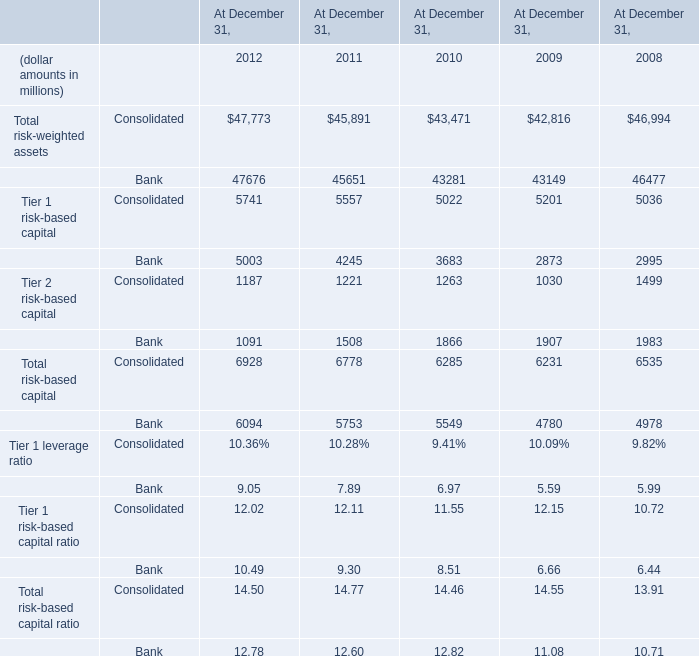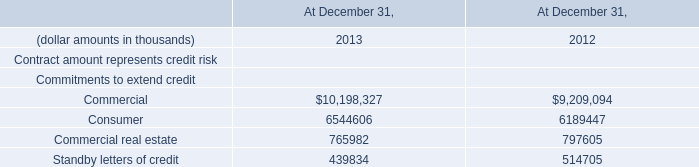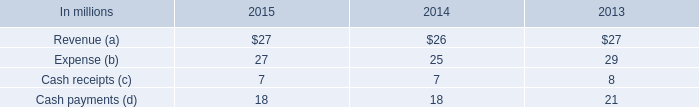what was the ratio of the fair value of international paper completed preliminary analysis of the acquisition date fair value of the borrowings in 2015 compared to 2014 
Computations: (1.97 / 2.16)
Answer: 0.91204. 